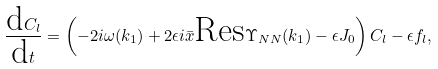<formula> <loc_0><loc_0><loc_500><loc_500>\frac { \text {d} C _ { l } } { \text {d} t } = \left ( - 2 i \omega ( k _ { 1 } ) + 2 \epsilon i \bar { x } \text {Res} \Upsilon _ { N N } ( k _ { 1 } ) - \epsilon J _ { 0 } \right ) C _ { l } - \epsilon f _ { l } ,</formula> 